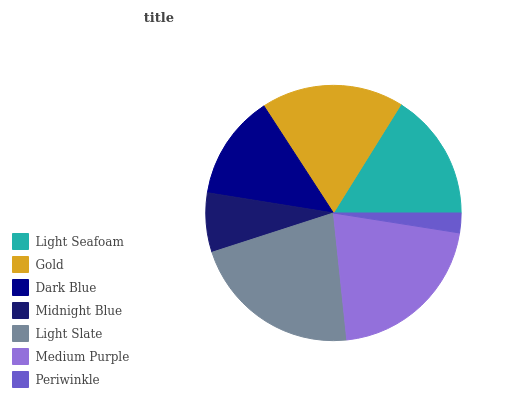Is Periwinkle the minimum?
Answer yes or no. Yes. Is Light Slate the maximum?
Answer yes or no. Yes. Is Gold the minimum?
Answer yes or no. No. Is Gold the maximum?
Answer yes or no. No. Is Gold greater than Light Seafoam?
Answer yes or no. Yes. Is Light Seafoam less than Gold?
Answer yes or no. Yes. Is Light Seafoam greater than Gold?
Answer yes or no. No. Is Gold less than Light Seafoam?
Answer yes or no. No. Is Light Seafoam the high median?
Answer yes or no. Yes. Is Light Seafoam the low median?
Answer yes or no. Yes. Is Medium Purple the high median?
Answer yes or no. No. Is Dark Blue the low median?
Answer yes or no. No. 